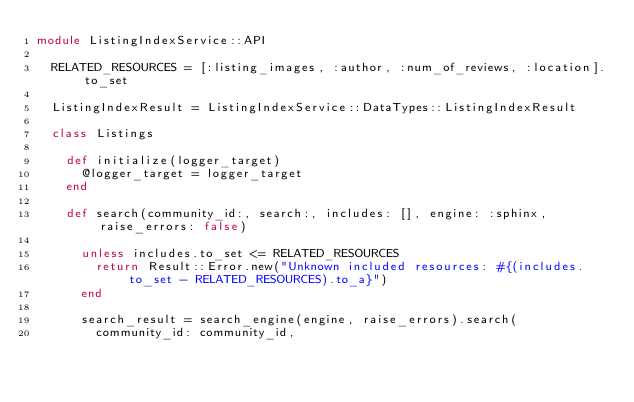Convert code to text. <code><loc_0><loc_0><loc_500><loc_500><_Ruby_>module ListingIndexService::API

  RELATED_RESOURCES = [:listing_images, :author, :num_of_reviews, :location].to_set

  ListingIndexResult = ListingIndexService::DataTypes::ListingIndexResult

  class Listings

    def initialize(logger_target)
      @logger_target = logger_target
    end

    def search(community_id:, search:, includes: [], engine: :sphinx, raise_errors: false)

      unless includes.to_set <= RELATED_RESOURCES
        return Result::Error.new("Unknown included resources: #{(includes.to_set - RELATED_RESOURCES).to_a}")
      end

      search_result = search_engine(engine, raise_errors).search(
        community_id: community_id,</code> 